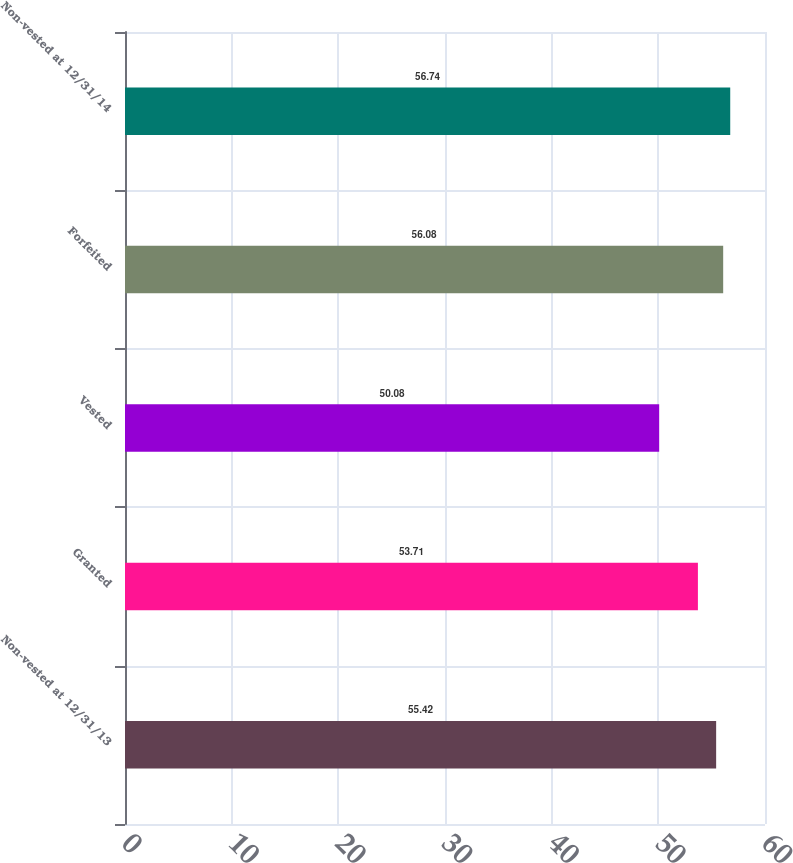Convert chart to OTSL. <chart><loc_0><loc_0><loc_500><loc_500><bar_chart><fcel>Non-vested at 12/31/13<fcel>Granted<fcel>Vested<fcel>Forfeited<fcel>Non-vested at 12/31/14<nl><fcel>55.42<fcel>53.71<fcel>50.08<fcel>56.08<fcel>56.74<nl></chart> 